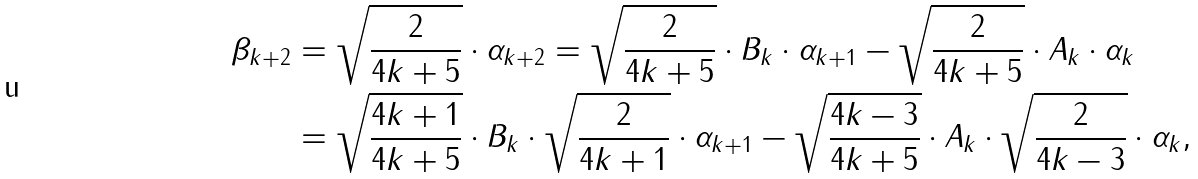<formula> <loc_0><loc_0><loc_500><loc_500>\beta _ { k + 2 } & = \sqrt { \frac { 2 } { 4 k + 5 } } \cdot \alpha _ { k + 2 } = \sqrt { \frac { 2 } { 4 k + 5 } } \cdot B _ { k } \cdot \alpha _ { k + 1 } - \sqrt { \frac { 2 } { 4 k + 5 } } \cdot A _ { k } \cdot \alpha _ { k } \\ & = \sqrt { \frac { 4 k + 1 } { 4 k + 5 } } \cdot B _ { k } \cdot \sqrt { \frac { 2 } { 4 k + 1 } } \cdot \alpha _ { k + 1 } - \sqrt { \frac { 4 k - 3 } { 4 k + 5 } } \cdot A _ { k } \cdot \sqrt { \frac { 2 } { 4 k - 3 } } \cdot \alpha _ { k } ,</formula> 